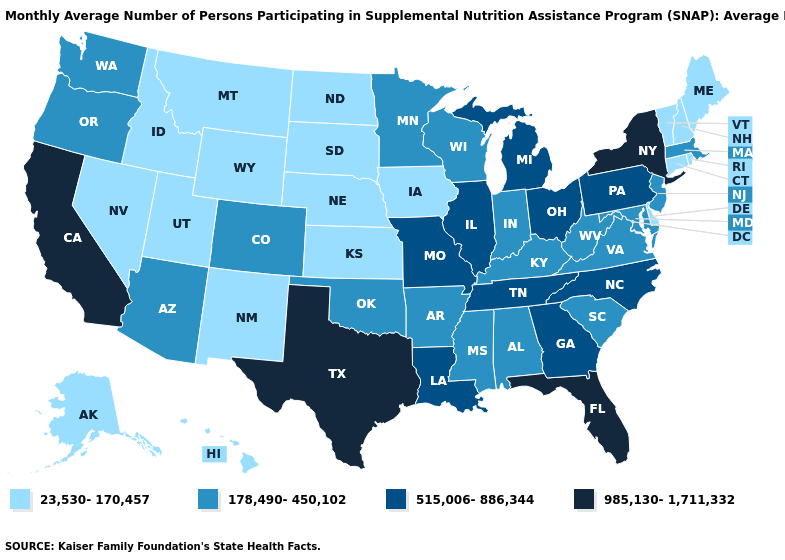Does Kansas have the highest value in the MidWest?
Give a very brief answer. No. Name the states that have a value in the range 985,130-1,711,332?
Give a very brief answer. California, Florida, New York, Texas. Does Maine have the lowest value in the Northeast?
Be succinct. Yes. Does Kansas have the same value as Iowa?
Write a very short answer. Yes. What is the value of Minnesota?
Answer briefly. 178,490-450,102. Name the states that have a value in the range 985,130-1,711,332?
Answer briefly. California, Florida, New York, Texas. Name the states that have a value in the range 23,530-170,457?
Concise answer only. Alaska, Connecticut, Delaware, Hawaii, Idaho, Iowa, Kansas, Maine, Montana, Nebraska, Nevada, New Hampshire, New Mexico, North Dakota, Rhode Island, South Dakota, Utah, Vermont, Wyoming. Does Florida have a lower value than Wisconsin?
Answer briefly. No. What is the value of Wisconsin?
Quick response, please. 178,490-450,102. Name the states that have a value in the range 985,130-1,711,332?
Short answer required. California, Florida, New York, Texas. Does Colorado have the same value as Connecticut?
Quick response, please. No. Among the states that border Oklahoma , does New Mexico have the lowest value?
Write a very short answer. Yes. Is the legend a continuous bar?
Answer briefly. No. 